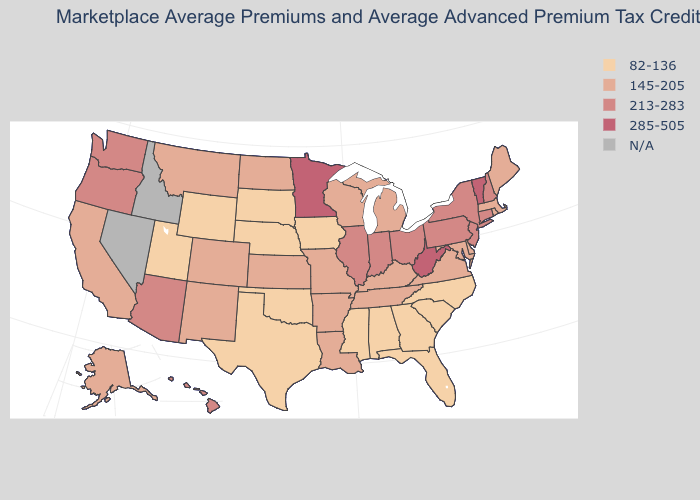Does the first symbol in the legend represent the smallest category?
Quick response, please. Yes. Name the states that have a value in the range 82-136?
Be succinct. Alabama, Florida, Georgia, Iowa, Mississippi, Nebraska, North Carolina, Oklahoma, South Carolina, South Dakota, Texas, Utah, Wyoming. What is the value of Arkansas?
Keep it brief. 145-205. Which states have the lowest value in the USA?
Answer briefly. Alabama, Florida, Georgia, Iowa, Mississippi, Nebraska, North Carolina, Oklahoma, South Carolina, South Dakota, Texas, Utah, Wyoming. What is the value of Virginia?
Answer briefly. 145-205. Is the legend a continuous bar?
Give a very brief answer. No. Among the states that border Oklahoma , which have the highest value?
Be succinct. Arkansas, Colorado, Kansas, Missouri, New Mexico. Name the states that have a value in the range 213-283?
Quick response, please. Arizona, Connecticut, Hawaii, Illinois, Indiana, New Hampshire, New Jersey, New York, Ohio, Oregon, Pennsylvania, Washington. Name the states that have a value in the range N/A?
Concise answer only. Idaho, Nevada. Which states have the highest value in the USA?
Keep it brief. Minnesota, Vermont, West Virginia. Does West Virginia have the highest value in the USA?
Concise answer only. Yes. What is the value of Colorado?
Answer briefly. 145-205. What is the value of Pennsylvania?
Short answer required. 213-283. 